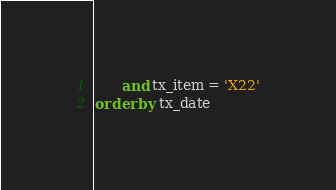<code> <loc_0><loc_0><loc_500><loc_500><_SQL_>      and tx_item = 'X22'
order by tx_date</code> 